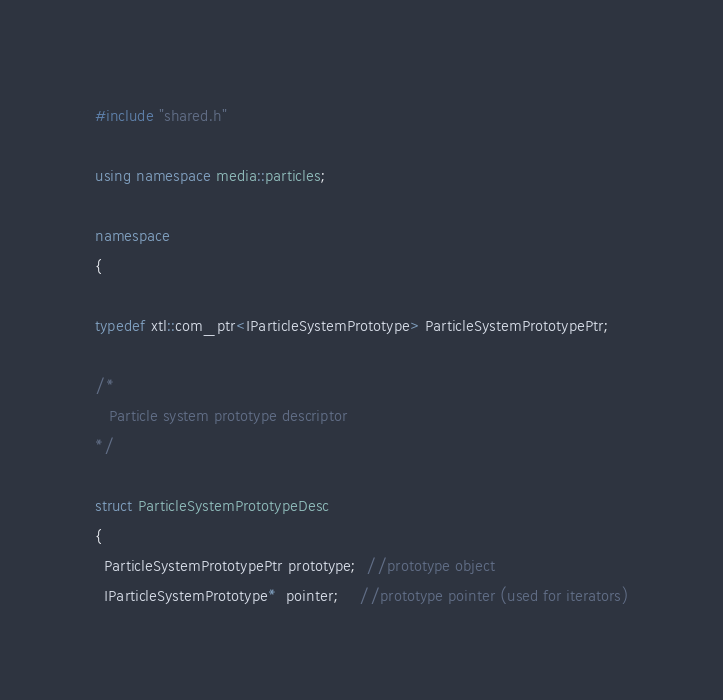Convert code to text. <code><loc_0><loc_0><loc_500><loc_500><_C++_>#include "shared.h"

using namespace media::particles;

namespace
{

typedef xtl::com_ptr<IParticleSystemPrototype> ParticleSystemPrototypePtr;

/*
   Particle system prototype descriptor
*/

struct ParticleSystemPrototypeDesc
{
  ParticleSystemPrototypePtr prototype;  //prototype object
  IParticleSystemPrototype*  pointer;    //prototype pointer (used for iterators)</code> 